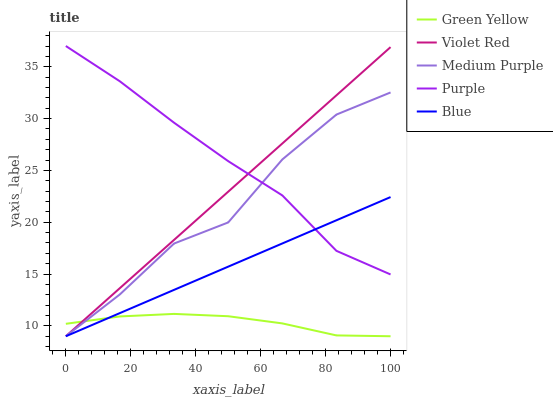Does Green Yellow have the minimum area under the curve?
Answer yes or no. Yes. Does Purple have the maximum area under the curve?
Answer yes or no. Yes. Does Violet Red have the minimum area under the curve?
Answer yes or no. No. Does Violet Red have the maximum area under the curve?
Answer yes or no. No. Is Violet Red the smoothest?
Answer yes or no. Yes. Is Medium Purple the roughest?
Answer yes or no. Yes. Is Purple the smoothest?
Answer yes or no. No. Is Purple the roughest?
Answer yes or no. No. Does Medium Purple have the lowest value?
Answer yes or no. Yes. Does Purple have the lowest value?
Answer yes or no. No. Does Purple have the highest value?
Answer yes or no. Yes. Does Violet Red have the highest value?
Answer yes or no. No. Is Green Yellow less than Purple?
Answer yes or no. Yes. Is Purple greater than Green Yellow?
Answer yes or no. Yes. Does Violet Red intersect Blue?
Answer yes or no. Yes. Is Violet Red less than Blue?
Answer yes or no. No. Is Violet Red greater than Blue?
Answer yes or no. No. Does Green Yellow intersect Purple?
Answer yes or no. No. 